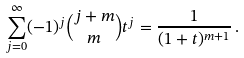Convert formula to latex. <formula><loc_0><loc_0><loc_500><loc_500>\sum ^ { \infty } _ { j = 0 } ( - 1 ) ^ { j } \binom { j + m } { m } t ^ { j } = \frac { 1 } { ( 1 + t ) ^ { m + 1 } } \, .</formula> 